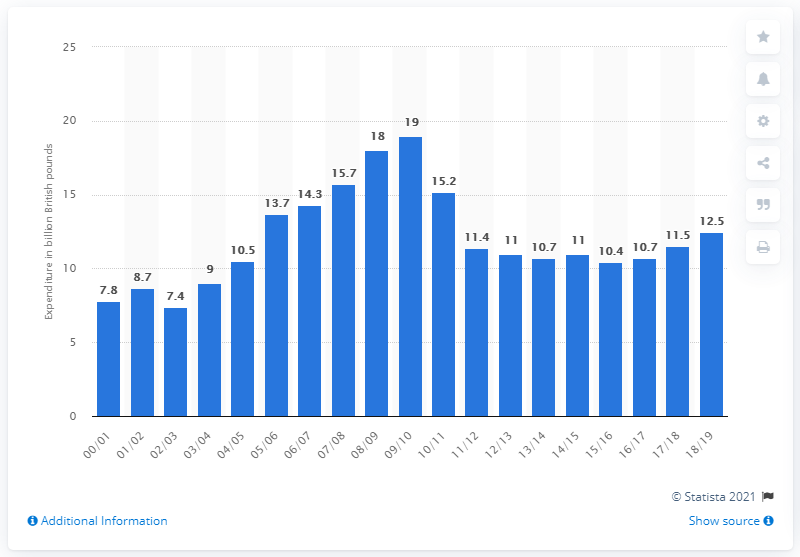Highlight a few significant elements in this photo. In 2009/10, the peak expenditure on housing and community amenities was 19.. 